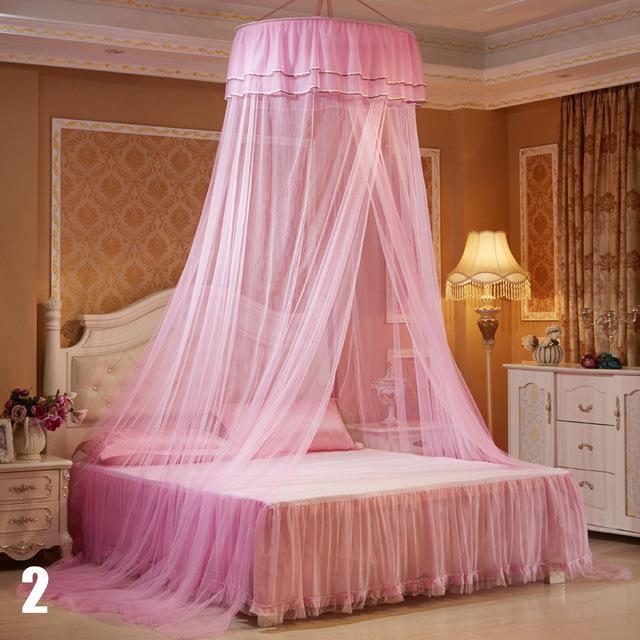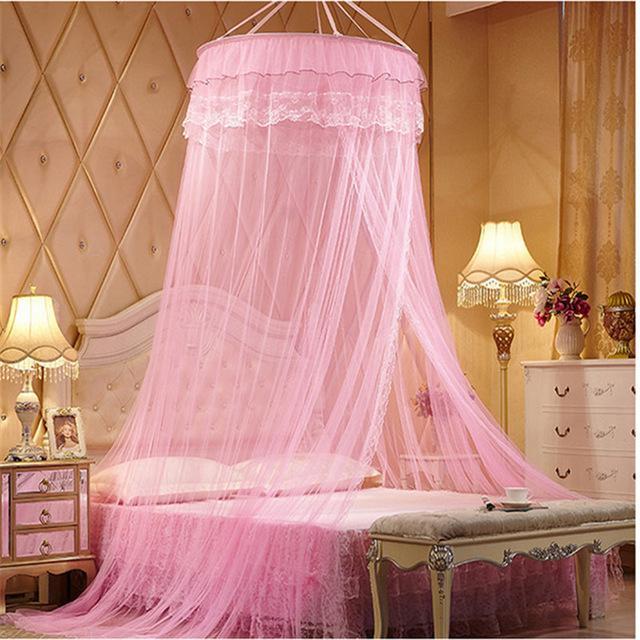The first image is the image on the left, the second image is the image on the right. Analyze the images presented: Is the assertion "At least one bed net is pink." valid? Answer yes or no. Yes. The first image is the image on the left, the second image is the image on the right. Assess this claim about the two images: "At least one image shows a gauzy canopy that drapes a bed from a round shape suspended from the ceiling, and at least one image features a pink canopy draping a bed.". Correct or not? Answer yes or no. Yes. 